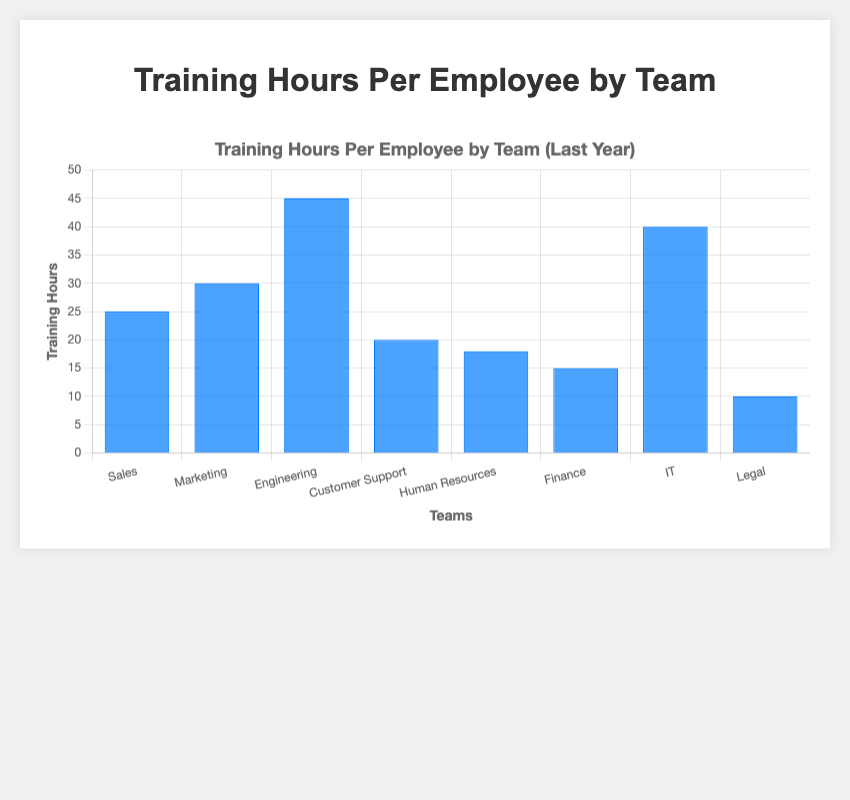Which team recorded the highest training hours per employee? The bar chart shows that the "Engineering" team has the highest value among all teams.
Answer: Engineering Which team spent less on training hours per employee compared to the Marketing team? The bar chart indicates that "Sales", "Customer Support", "Human Resources", "Finance", "IT", and "Legal" all recorded fewer training hours per employee compared to the "Marketing" team.
Answer: Sales, Customer Support, Human Resources, Finance, IT, Legal What is the total training hours per employee for the "Finance" and "Legal" teams? The "Finance" team has 15 hours per employee, and the "Legal" team has 10 hours per employee. Summing these gives 15 + 10 = 25 hours.
Answer: 25 What is the difference in training hours per employee between the "Engineering" and "Finance" teams? The "Engineering" team has 45 hours per employee and the "Finance" team has 15 hours per employee. The difference is 45 - 15 = 30 hours.
Answer: 30 Which team spent exactly 40 training hours per employee? The bar chart shows that the "IT" team recorded exactly 40 training hours per employee.
Answer: IT Summing the training hours per employee for the "Sales", "Marketing", and "Engineering" teams, what do you get? The training hours per employee are 25 for "Sales", 30 for "Marketing", and 45 for "Engineering". Summing these gives 25 + 30 + 45 = 100 hours.
Answer: 100 How does the "Customer Support" team compare to the "IT" team in terms of training hours per employee? The "Customer Support" team has 20 hours per employee, while the "IT" team has 40 hours. Therefore, "Customer Support" has fewer training hours per employee than "IT".
Answer: Fewer What is the median training hours per employee if the teams are sorted by training hours? The sorted values are 10, 15, 18, 20, 25, 30, 40, 45. The median is the average of the 4th and 5th values: (20 + 25) / 2 = 22.5 hours.
Answer: 22.5 What is the range of training hours per employee across all teams? The highest value is for "Engineering" at 45 hours, and the lowest is for "Legal" at 10 hours. The range is 45 - 10 = 35 hours.
Answer: 35 